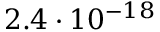Convert formula to latex. <formula><loc_0><loc_0><loc_500><loc_500>2 . 4 \cdot 1 0 ^ { - 1 8 }</formula> 